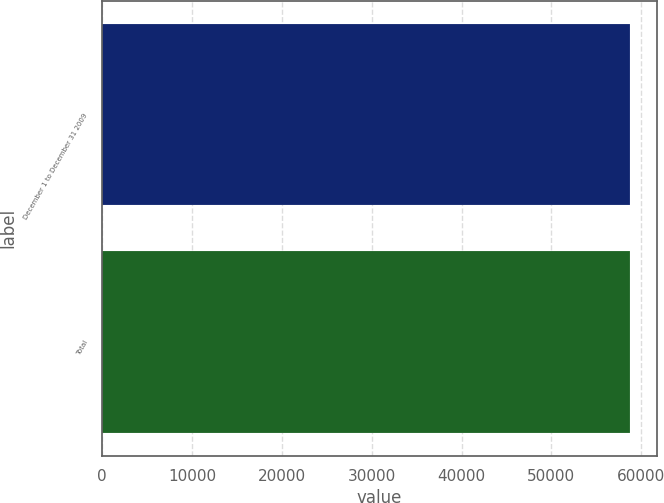Convert chart. <chart><loc_0><loc_0><loc_500><loc_500><bar_chart><fcel>December 1 to December 31 2009<fcel>Total<nl><fcel>58800<fcel>58800.1<nl></chart> 